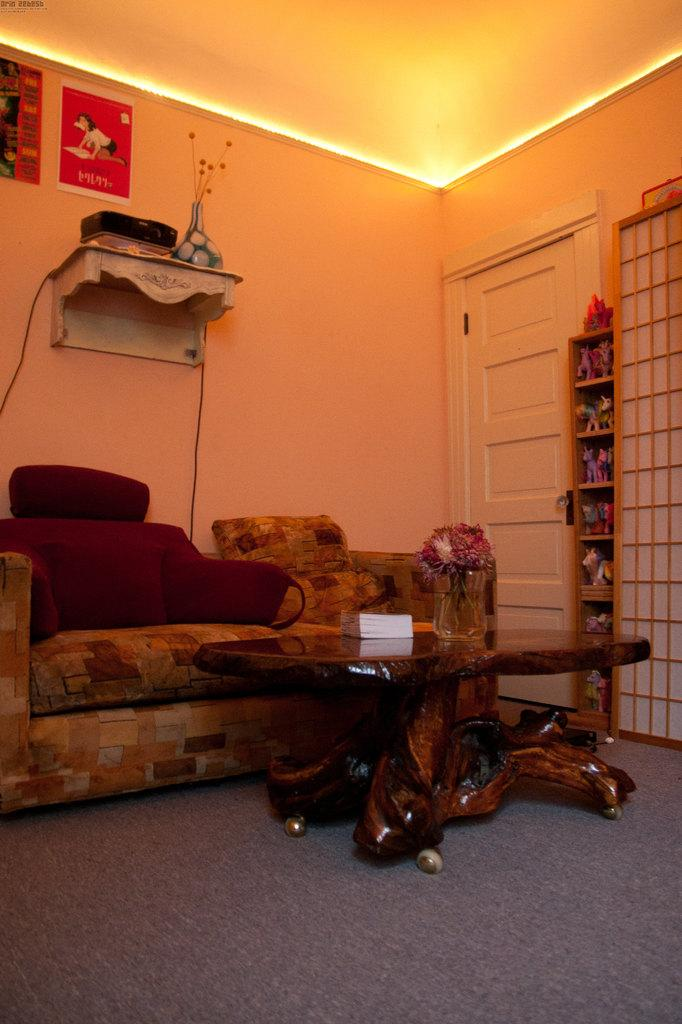What type of space is shown in the image? The image is an inside view of a room. What furniture is present in the room? There is a sofa and a table in the room. What object can be seen on the table? There is a book on the table. What architectural features are present in the room? There is a wall and a door in the room. Can you tell me how many donkeys are visible in the room? There are no donkeys present in the image; it shows an inside view of a room with a sofa, table, book, wall, and door. What type of library is featured in the image? There is no library present in the image; it shows an inside view of a room with a sofa, table, book, wall, and door. 